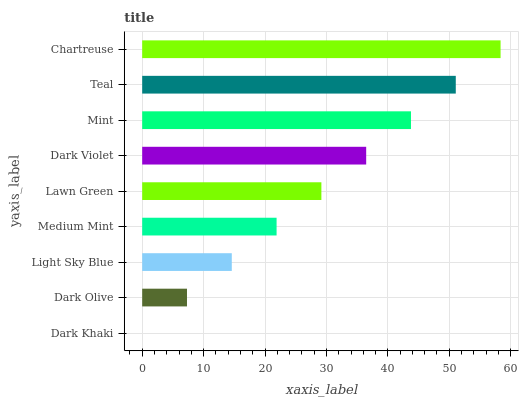Is Dark Khaki the minimum?
Answer yes or no. Yes. Is Chartreuse the maximum?
Answer yes or no. Yes. Is Dark Olive the minimum?
Answer yes or no. No. Is Dark Olive the maximum?
Answer yes or no. No. Is Dark Olive greater than Dark Khaki?
Answer yes or no. Yes. Is Dark Khaki less than Dark Olive?
Answer yes or no. Yes. Is Dark Khaki greater than Dark Olive?
Answer yes or no. No. Is Dark Olive less than Dark Khaki?
Answer yes or no. No. Is Lawn Green the high median?
Answer yes or no. Yes. Is Lawn Green the low median?
Answer yes or no. Yes. Is Medium Mint the high median?
Answer yes or no. No. Is Teal the low median?
Answer yes or no. No. 